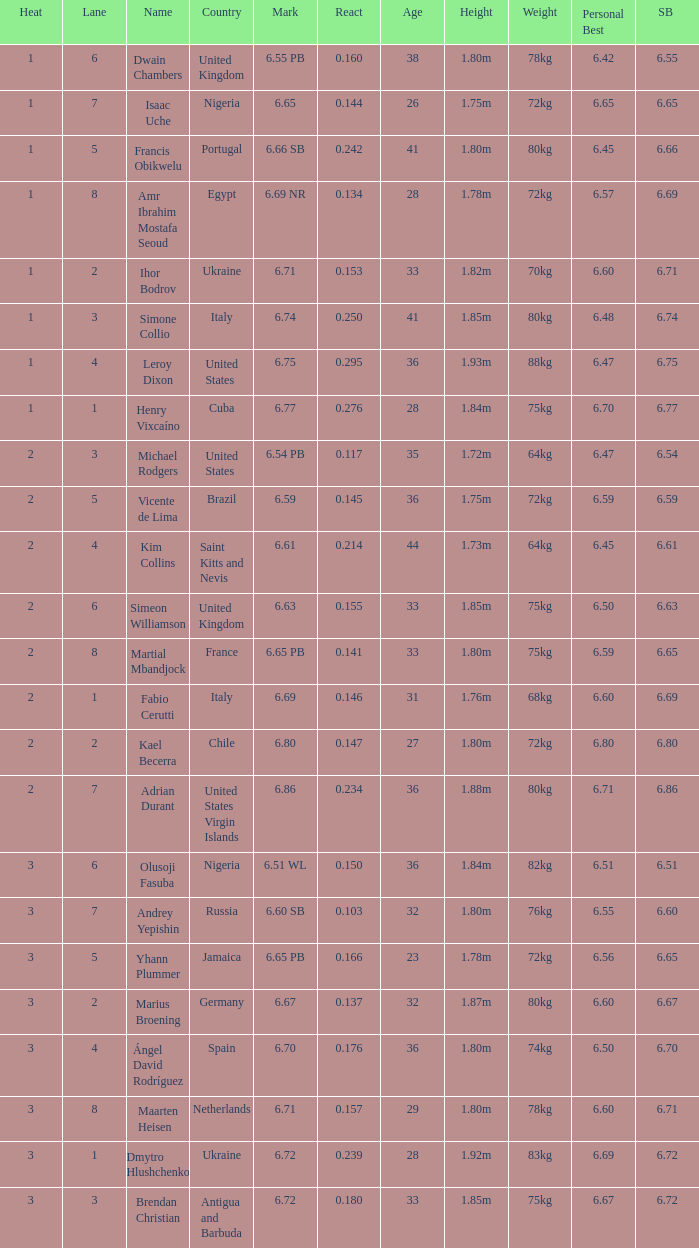What is Heat, when Mark is 6.69? 2.0. 